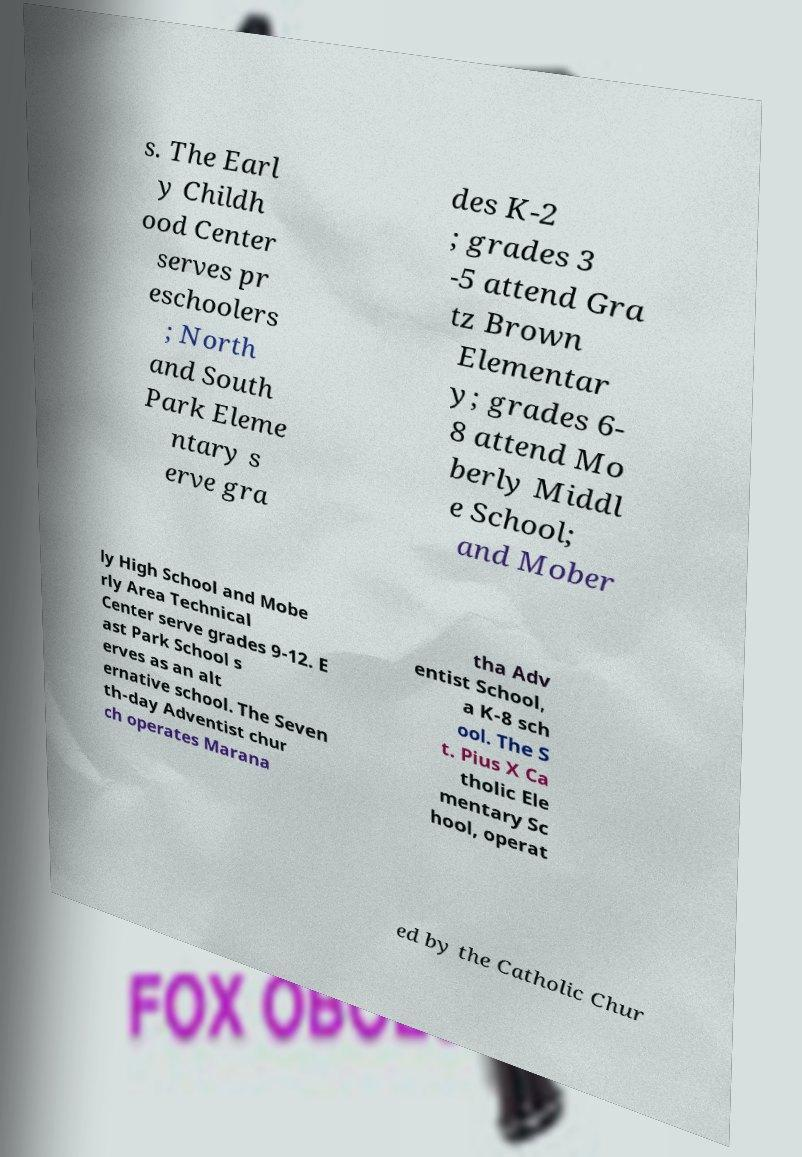Can you accurately transcribe the text from the provided image for me? s. The Earl y Childh ood Center serves pr eschoolers ; North and South Park Eleme ntary s erve gra des K-2 ; grades 3 -5 attend Gra tz Brown Elementar y; grades 6- 8 attend Mo berly Middl e School; and Mober ly High School and Mobe rly Area Technical Center serve grades 9-12. E ast Park School s erves as an alt ernative school. The Seven th-day Adventist chur ch operates Marana tha Adv entist School, a K-8 sch ool. The S t. Pius X Ca tholic Ele mentary Sc hool, operat ed by the Catholic Chur 